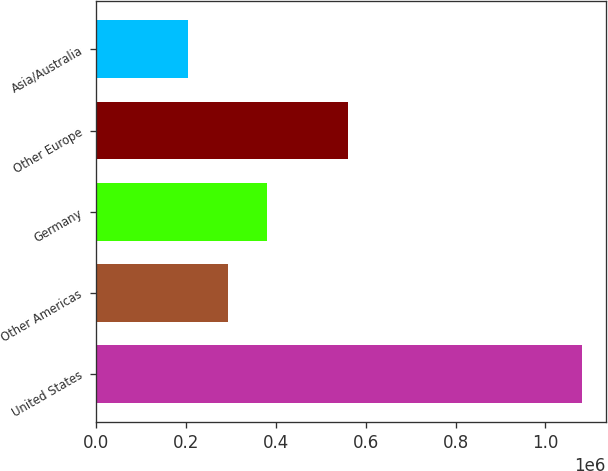Convert chart. <chart><loc_0><loc_0><loc_500><loc_500><bar_chart><fcel>United States<fcel>Other Americas<fcel>Germany<fcel>Other Europe<fcel>Asia/Australia<nl><fcel>1.08074e+06<fcel>292441<fcel>380029<fcel>560038<fcel>204853<nl></chart> 